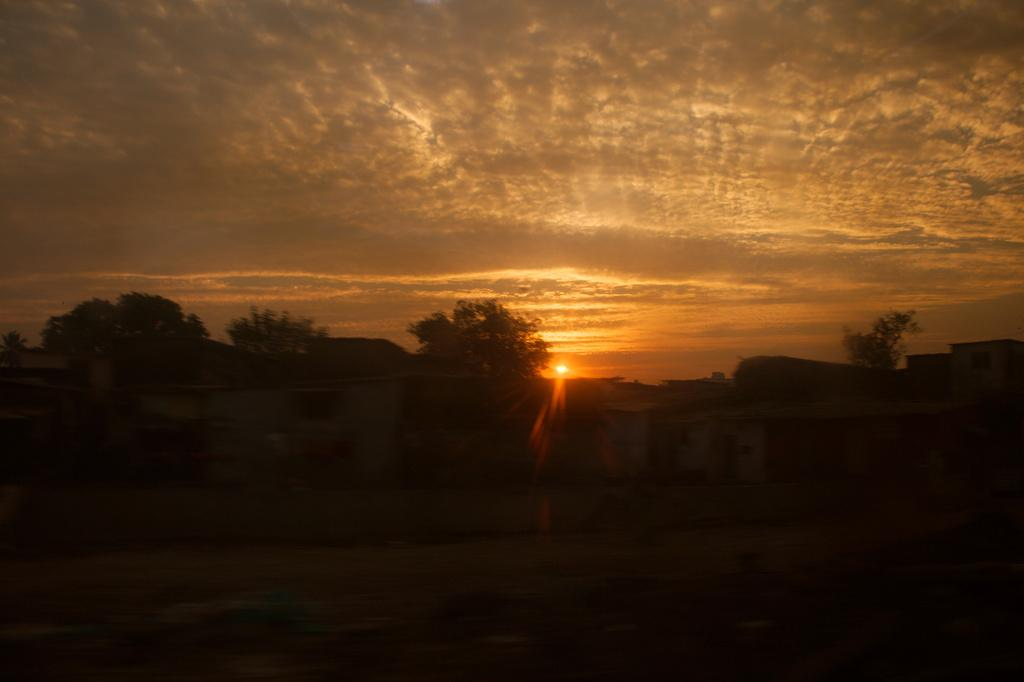What type of vegetation is visible in the image? There are trees in the image. What type of structures can be seen in the image? There are sheds in the image. What time of day is depicted in the image? The image depicts a sunset. How many girls are resting in the sheds during the sunset in the image? There are no girls or resting activities depicted in the image; it features trees, sheds, and a sunset. 